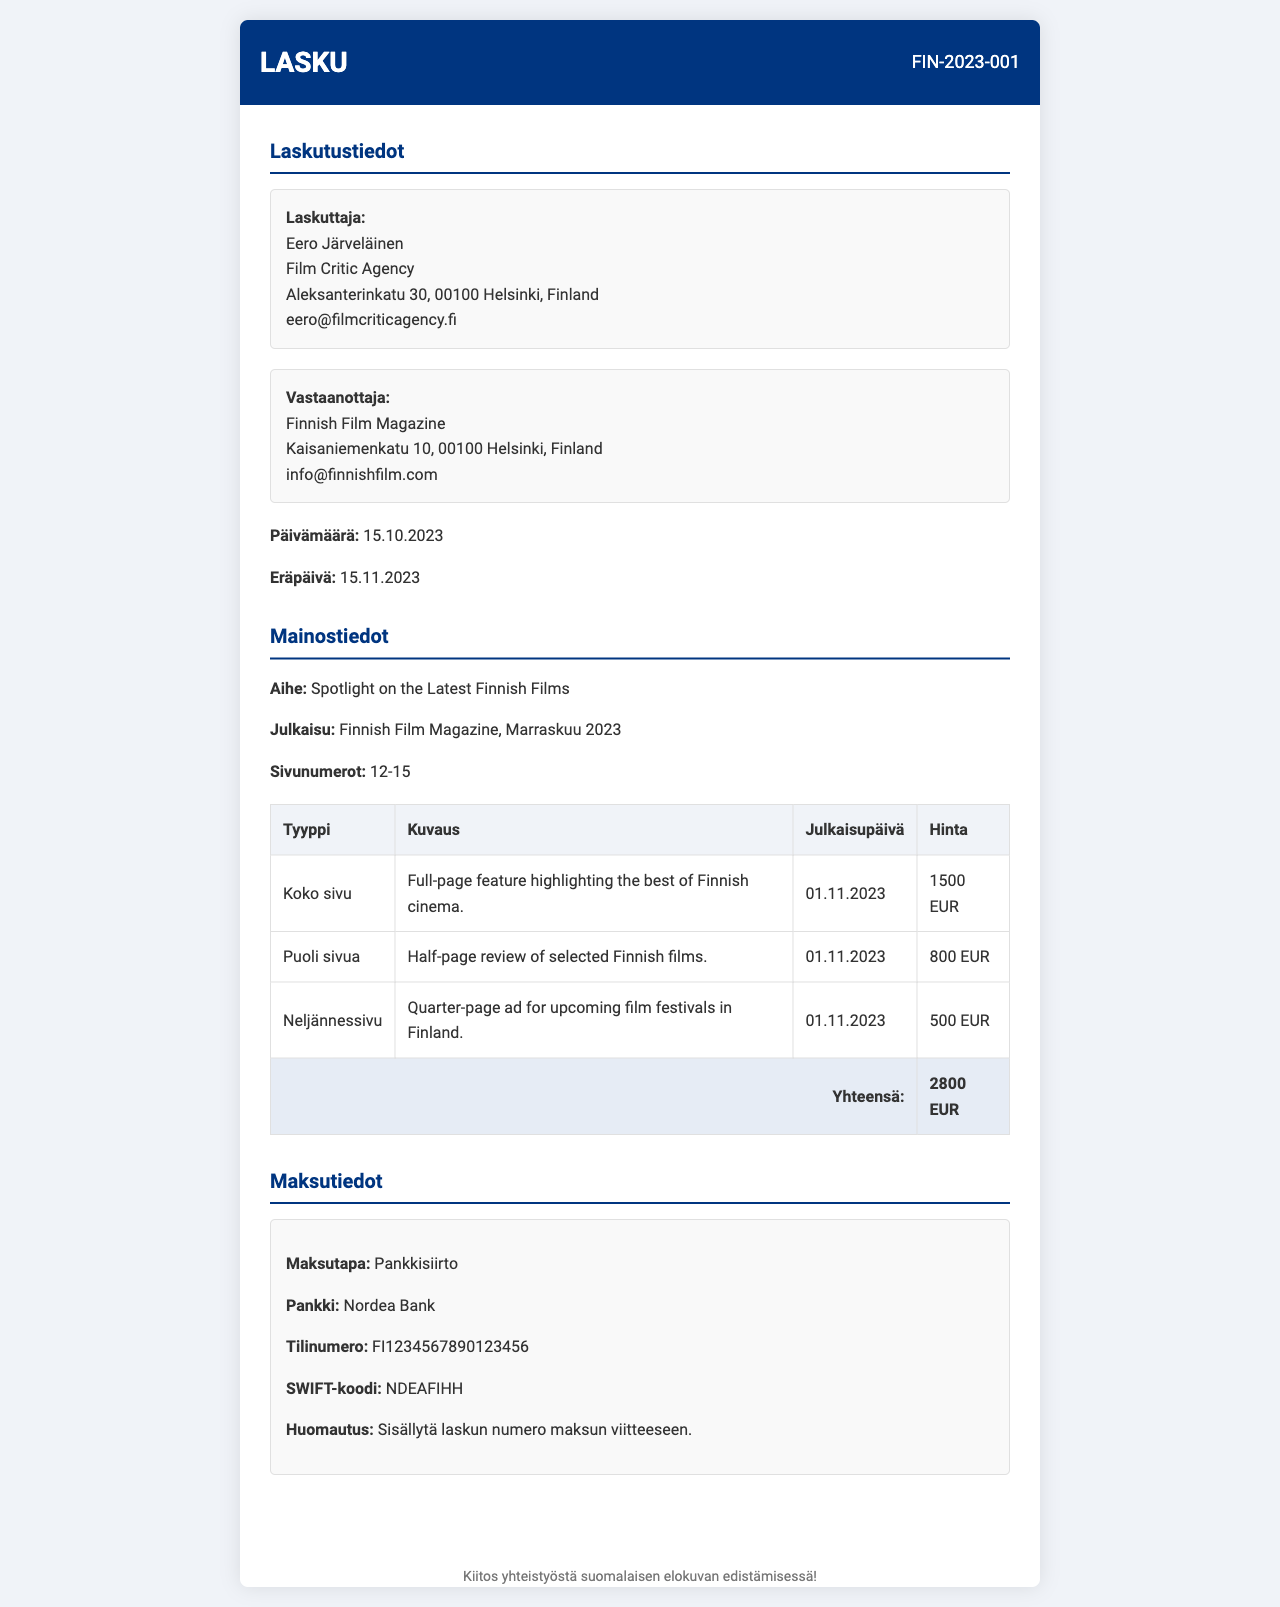What is the invoice number? The invoice number is stated in the invoice header as "FIN-2023-001".
Answer: FIN-2023-001 Who is the issuer of the invoice? The issuer's name and organization are provided in the invoice under "Laskuttaja", which is "Eero Järveläinen" from "Film Critic Agency".
Answer: Eero Järveläinen What is the total amount due? The total amount due is listed at the bottom of the advertising details as "Yhteensä: 2800 EUR".
Answer: 2800 EUR What is the publication date of the magazine? The publication date is mentioned in the "Julkaisu" section as "Marraskuu 2023".
Answer: Marraskuu 2023 How many types of ads are listed in the document? The document includes three types of ads as detailed in the "Mainostiedot" section.
Answer: 3 What is the payment method specified? The payment method is stated in the "Maksutiedot" section as "Pankkisiirto".
Answer: Pankkisiirto When is the due date for payment? The due date for payment is indicated as "15.11.2023".
Answer: 15.11.2023 What is the description of the quarter-page ad? The description for the quarter-page ad is provided in the ad table as "Quarter-page ad for upcoming film festivals in Finland".
Answer: Quarter-page ad for upcoming film festivals in Finland 